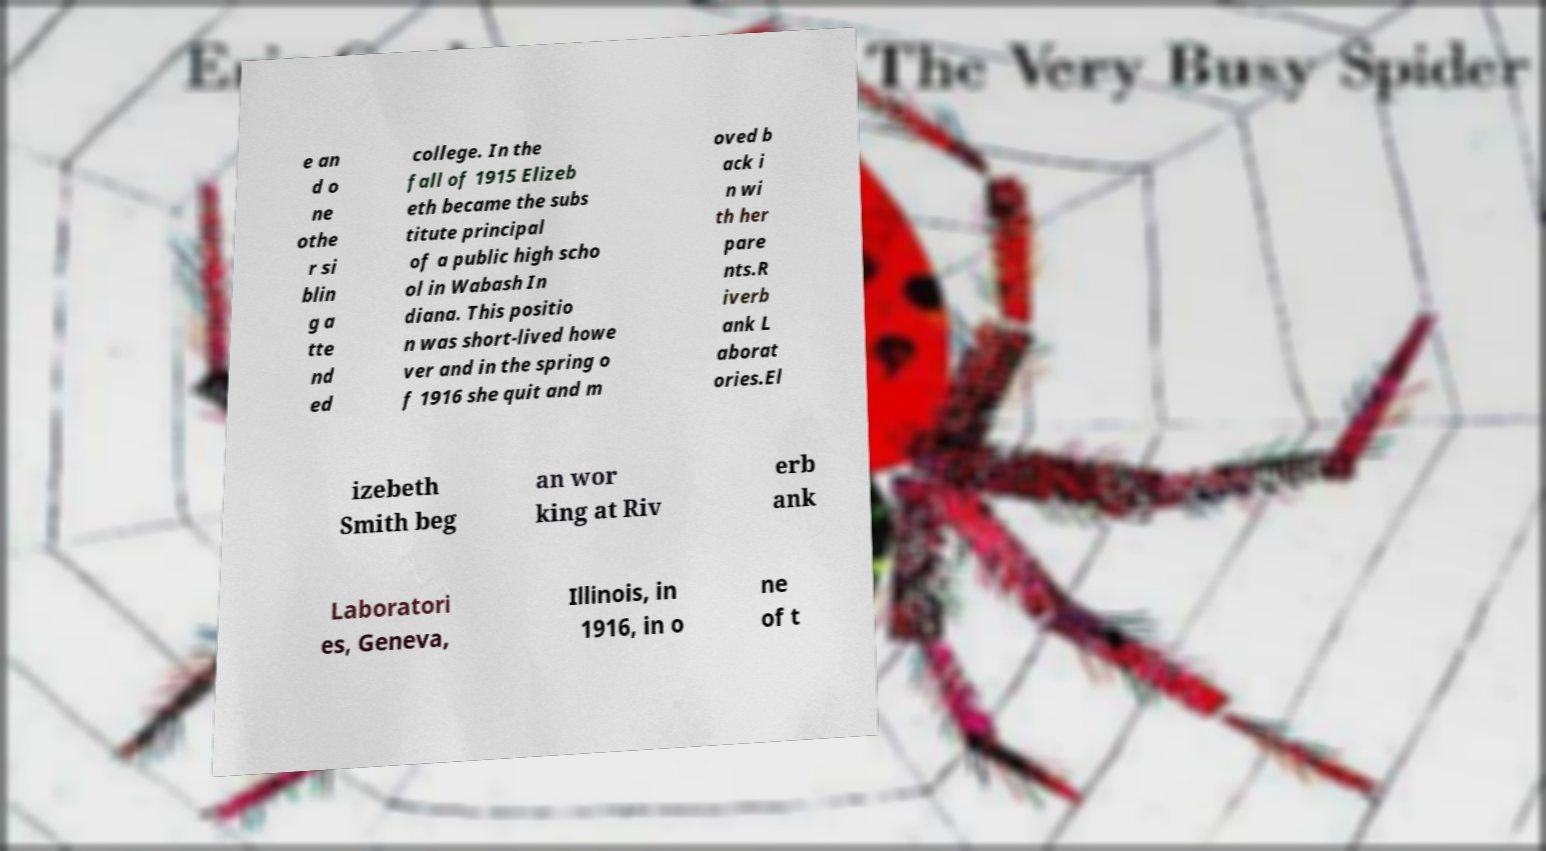Please read and relay the text visible in this image. What does it say? e an d o ne othe r si blin g a tte nd ed college. In the fall of 1915 Elizeb eth became the subs titute principal of a public high scho ol in Wabash In diana. This positio n was short-lived howe ver and in the spring o f 1916 she quit and m oved b ack i n wi th her pare nts.R iverb ank L aborat ories.El izebeth Smith beg an wor king at Riv erb ank Laboratori es, Geneva, Illinois, in 1916, in o ne of t 